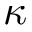Convert formula to latex. <formula><loc_0><loc_0><loc_500><loc_500>\kappa</formula> 